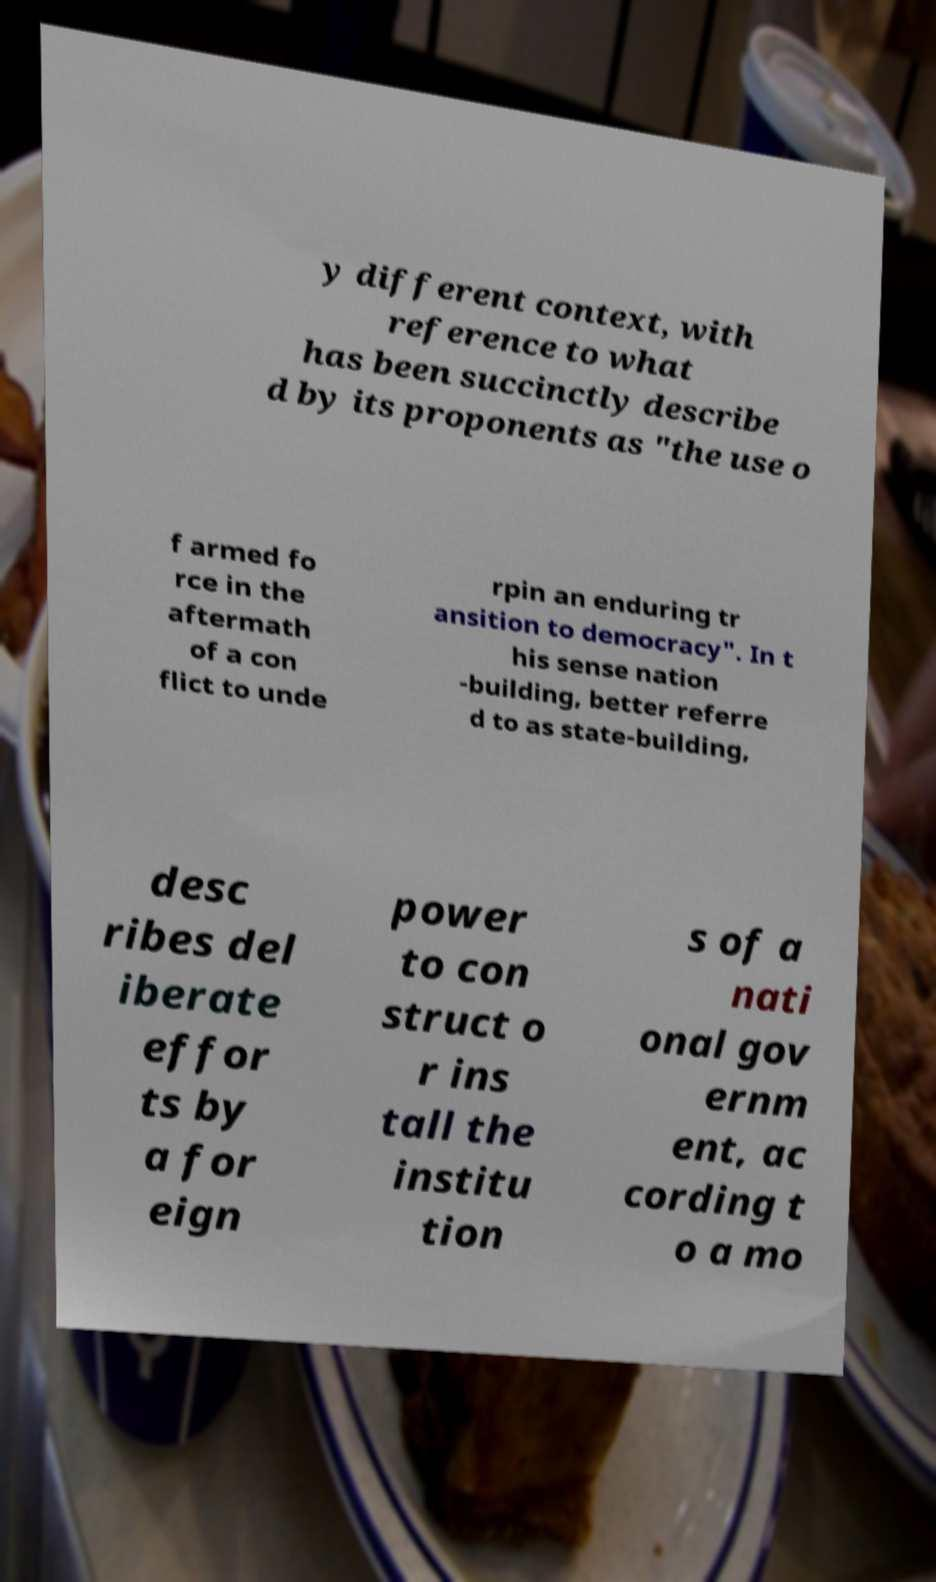Could you extract and type out the text from this image? y different context, with reference to what has been succinctly describe d by its proponents as "the use o f armed fo rce in the aftermath of a con flict to unde rpin an enduring tr ansition to democracy". In t his sense nation -building, better referre d to as state-building, desc ribes del iberate effor ts by a for eign power to con struct o r ins tall the institu tion s of a nati onal gov ernm ent, ac cording t o a mo 